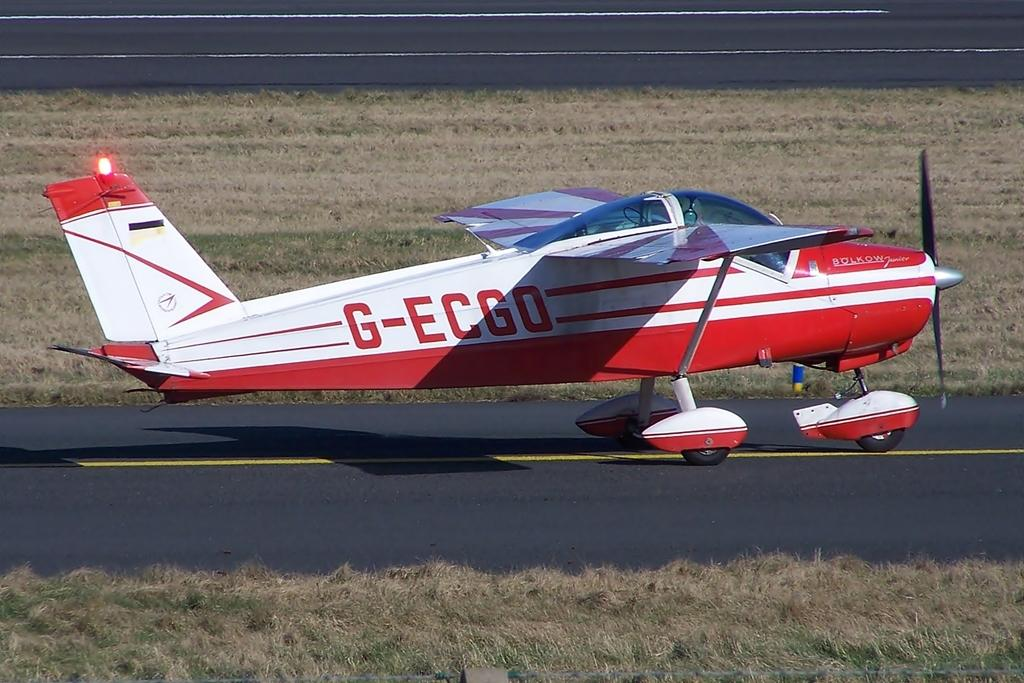What is the main subject of the image? The main subject of the image is a jet plane. What colors can be seen on the jet plane? The jet plane is white and red in color. What is located at the bottom of the image? There is a road at the bottom of the image. What type of vegetation is visible in the image? Dry grass is visible in the image. What type of light can be seen shining on the celery in the image? There is no celery present in the image, and therefore no light shining on it. What type of flesh can be seen on the jet plane in the image? There is no flesh present on the jet plane in the image; it is a mechanical object made of metal and other materials. 